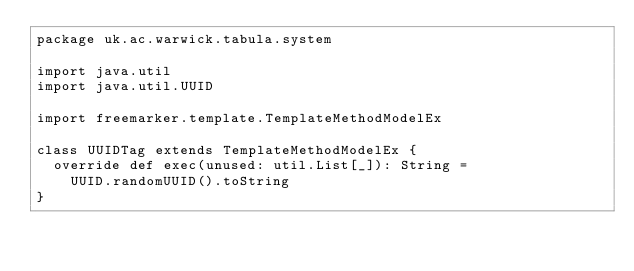Convert code to text. <code><loc_0><loc_0><loc_500><loc_500><_Scala_>package uk.ac.warwick.tabula.system

import java.util
import java.util.UUID

import freemarker.template.TemplateMethodModelEx

class UUIDTag extends TemplateMethodModelEx {
  override def exec(unused: util.List[_]): String =
    UUID.randomUUID().toString
}
</code> 